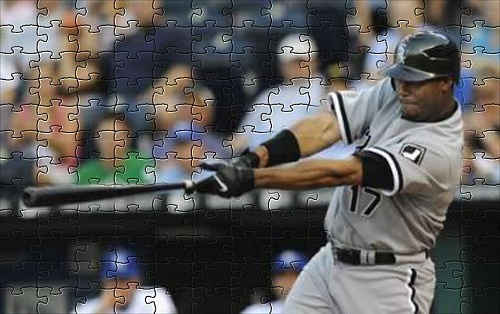Describe the objects in this image and their specific colors. I can see people in gray, darkgray, black, and lightgray tones, people in gray, darkgray, and black tones, people in gray, lightgray, and darkgray tones, people in gray, black, and green tones, and people in gray, lavender, black, and navy tones in this image. 